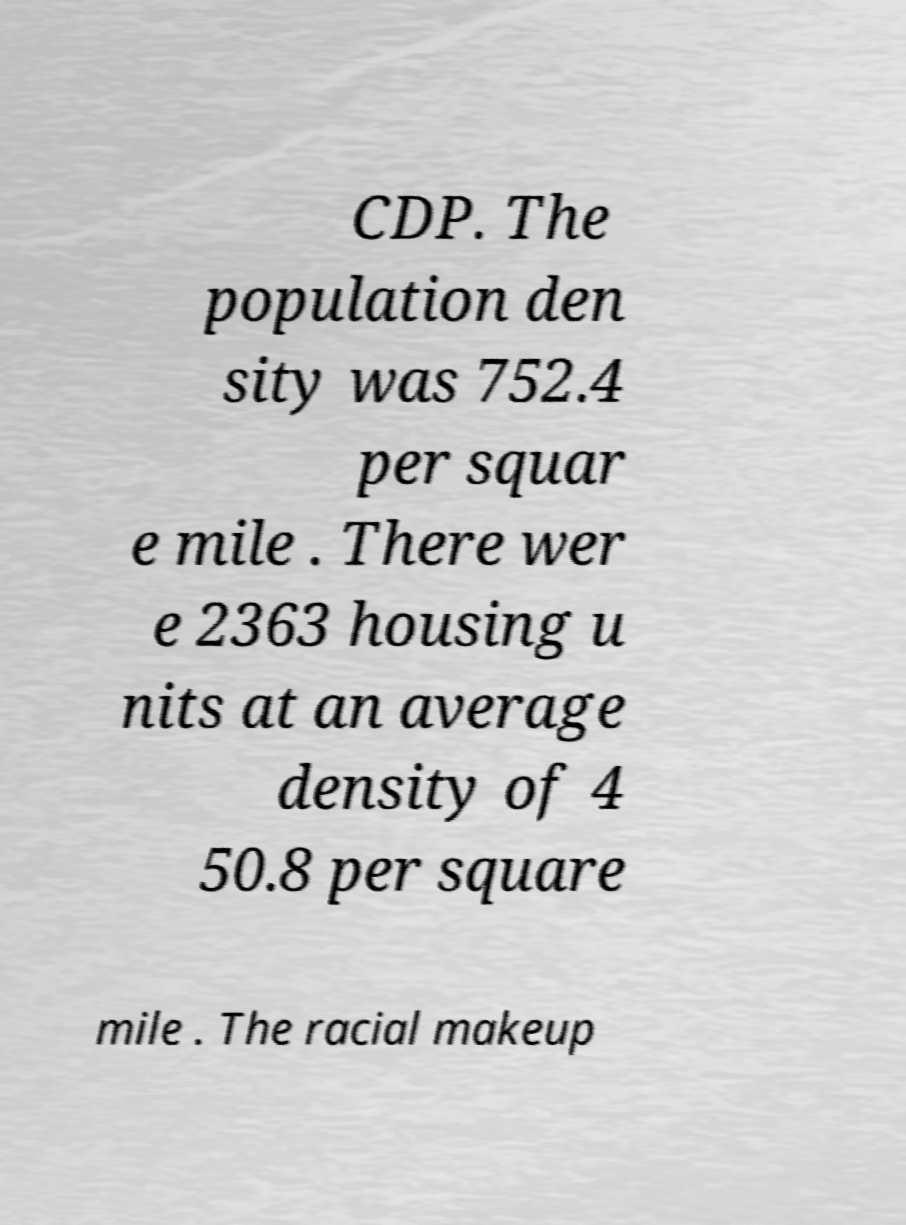I need the written content from this picture converted into text. Can you do that? CDP. The population den sity was 752.4 per squar e mile . There wer e 2363 housing u nits at an average density of 4 50.8 per square mile . The racial makeup 